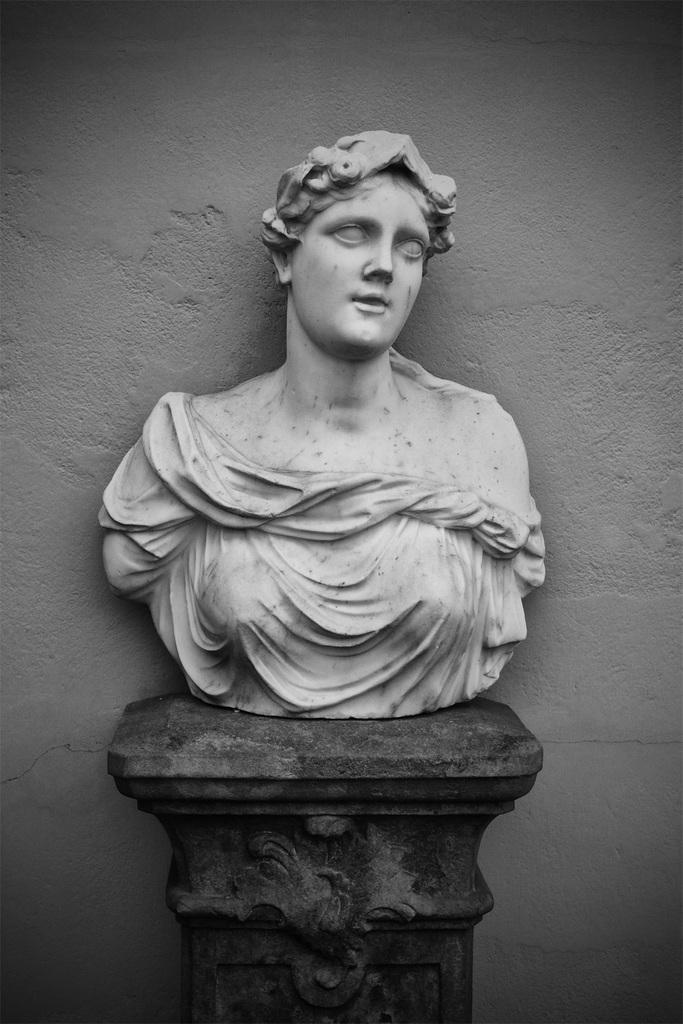What is the main subject of the image? There is a statue of a woman in the image. Can you describe the statue's surroundings? There is a wall in the background of the image. How many eggs are on the statue's hair in the image? There are no eggs present on the statue's hair in the image. Is there a volleyball game happening in the background of the image? There is no volleyball game present in the image; it only features a statue of a woman and a wall in the background. 